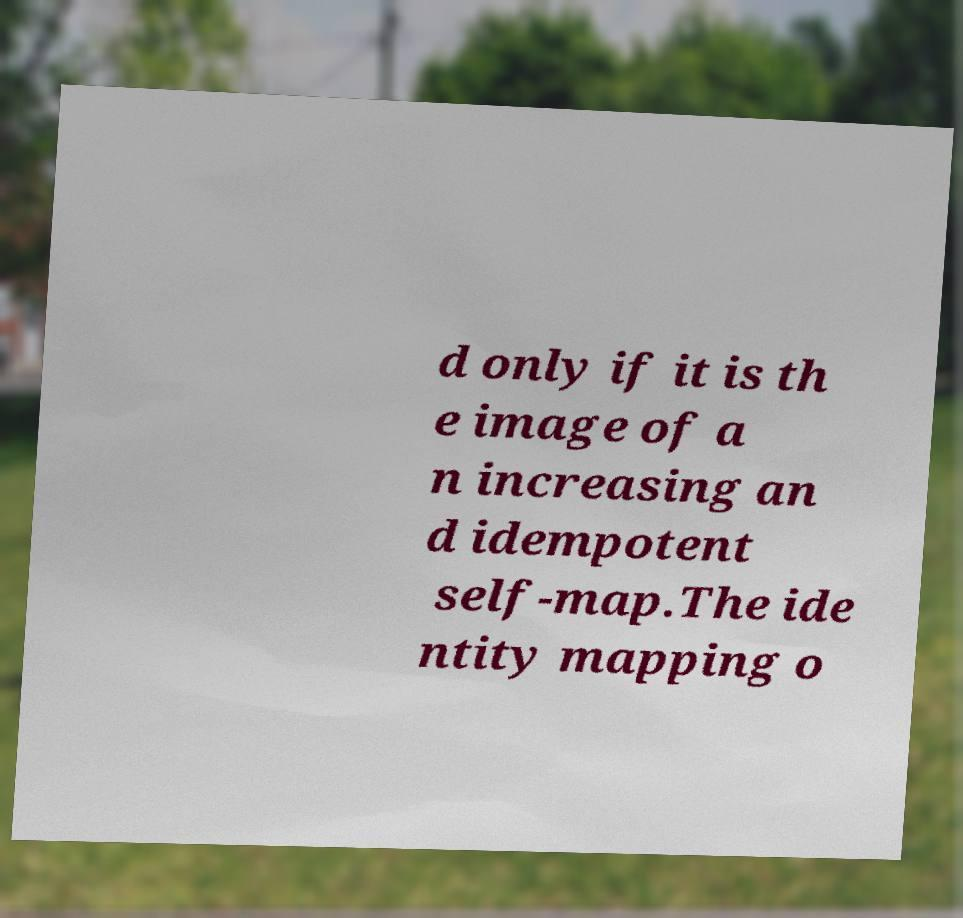What messages or text are displayed in this image? I need them in a readable, typed format. d only if it is th e image of a n increasing an d idempotent self-map.The ide ntity mapping o 